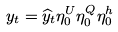Convert formula to latex. <formula><loc_0><loc_0><loc_500><loc_500>y _ { t } = \widehat { y } _ { t } \eta ^ { U } _ { 0 } \eta ^ { Q } _ { 0 } \eta ^ { h } _ { 0 }</formula> 